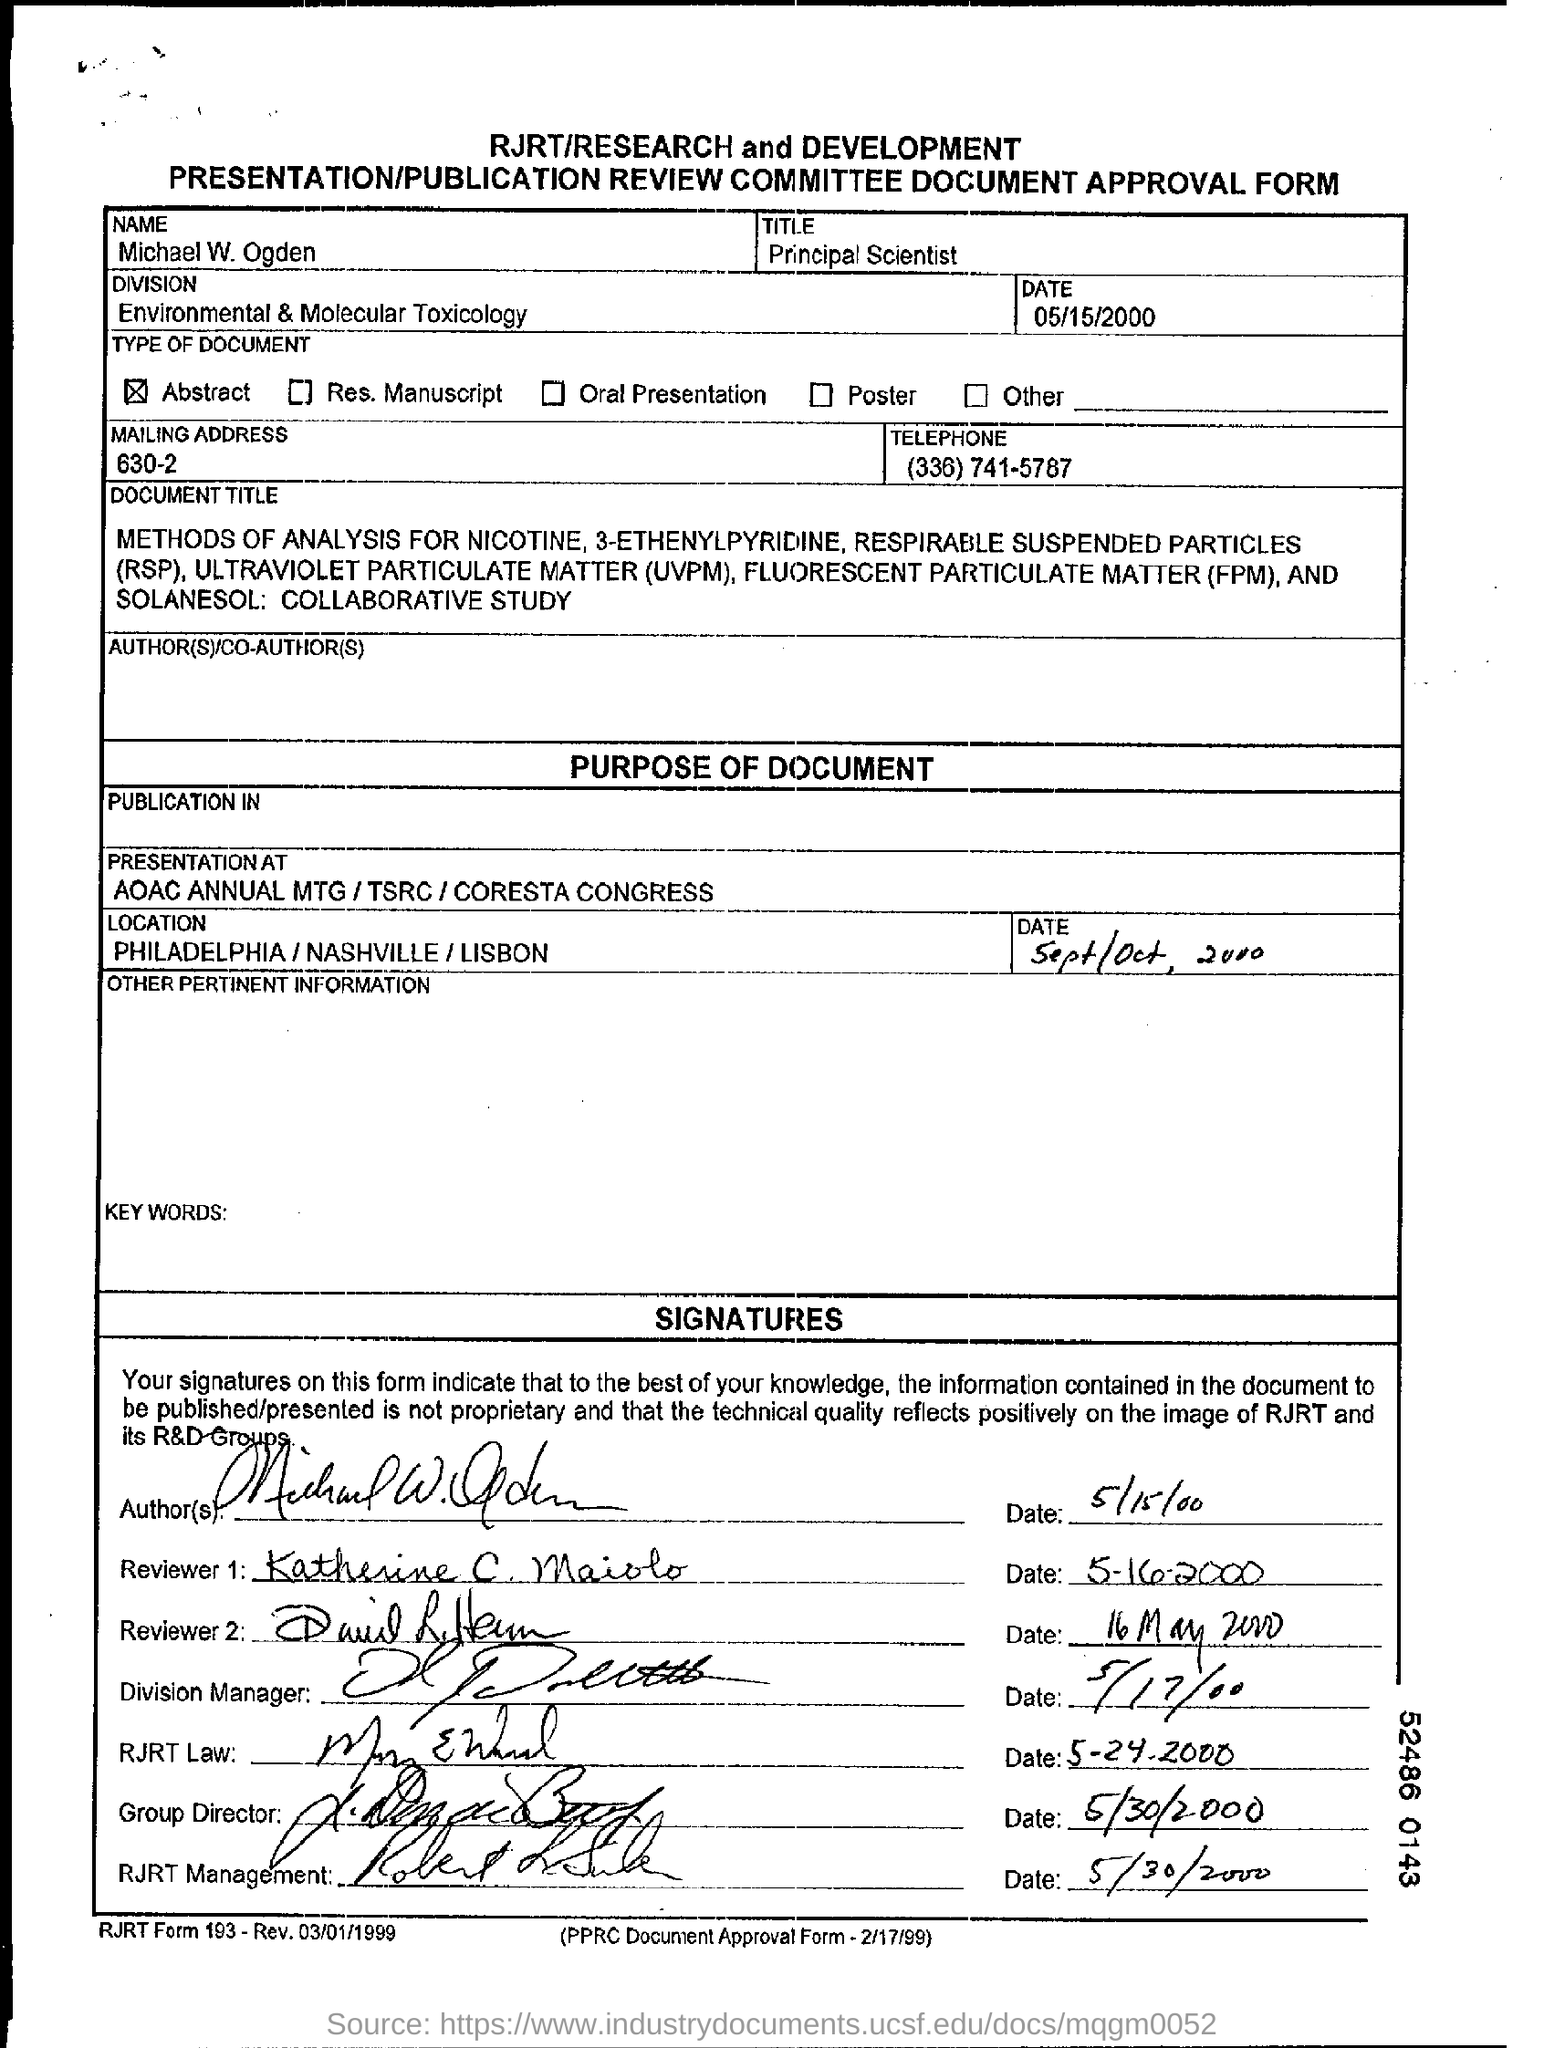What is the date mentioned in the top of the document ?
Provide a succinct answer. 05/15/2000. What is written in the Title Field ?
Your answer should be very brief. Principal Scientist. What is written in the Name Field ?
Make the answer very short. Michael W. Ogden. What is the Telephone Number ?
Keep it short and to the point. (336) 741-5787. What is written in  the Division Field ?
Offer a very short reply. Environmental & Molecular Toxicology. 